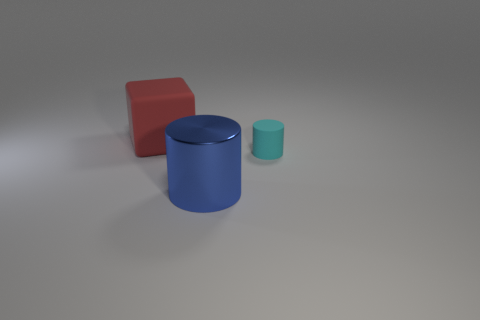Could you describe the mood or atmosphere of this setup? The setup has a minimalist and clean aesthetic, with a neutral grey background which suggests a calm and controlled atmosphere, suitable for highlighting objects without distraction. 